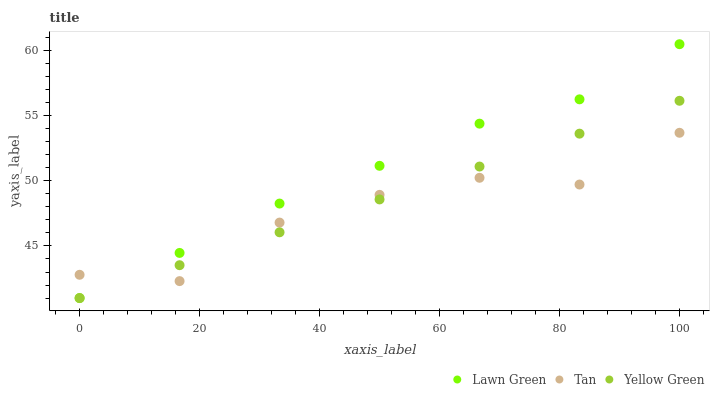Does Tan have the minimum area under the curve?
Answer yes or no. Yes. Does Lawn Green have the maximum area under the curve?
Answer yes or no. Yes. Does Yellow Green have the minimum area under the curve?
Answer yes or no. No. Does Yellow Green have the maximum area under the curve?
Answer yes or no. No. Is Yellow Green the smoothest?
Answer yes or no. Yes. Is Tan the roughest?
Answer yes or no. Yes. Is Tan the smoothest?
Answer yes or no. No. Is Yellow Green the roughest?
Answer yes or no. No. Does Lawn Green have the lowest value?
Answer yes or no. Yes. Does Tan have the lowest value?
Answer yes or no. No. Does Lawn Green have the highest value?
Answer yes or no. Yes. Does Yellow Green have the highest value?
Answer yes or no. No. Does Yellow Green intersect Lawn Green?
Answer yes or no. Yes. Is Yellow Green less than Lawn Green?
Answer yes or no. No. Is Yellow Green greater than Lawn Green?
Answer yes or no. No. 